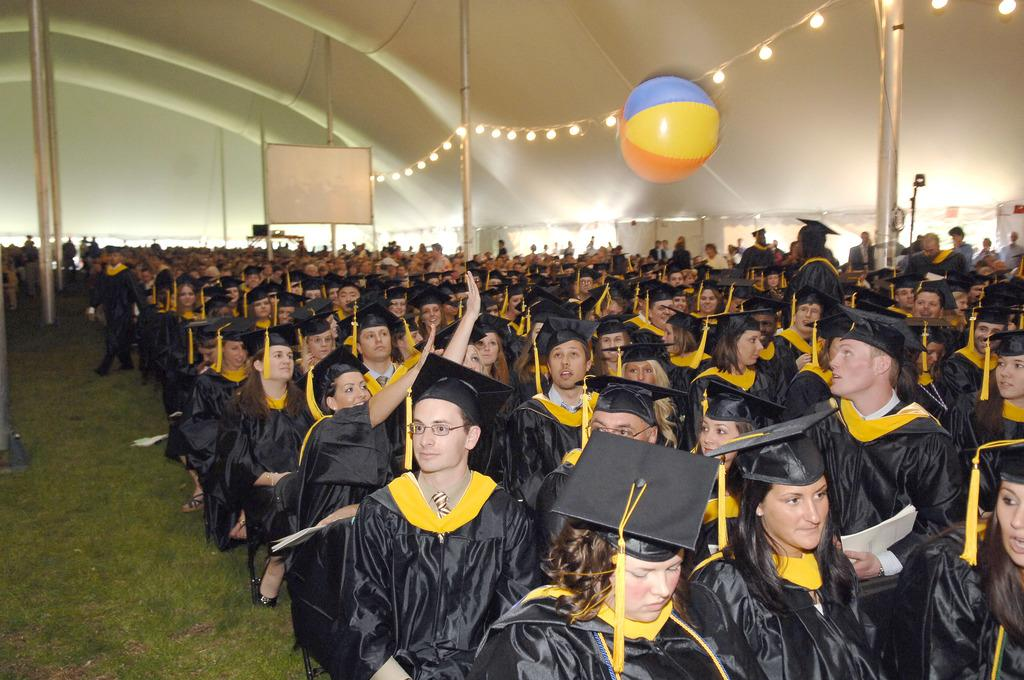How many students are present in the image? There are many students in the image. Where are the students sitting in the image? The students are sitting on the right side. What else can be seen in the image besides the students? There are poles and a whiteboard in the image. What might be used for displaying information or writing during a class? The whiteboard in the middle of the image can be used for displaying information or writing during a class. What type of whip is being used by the authority figure in the image? There is no authority figure or whip present in the image. 